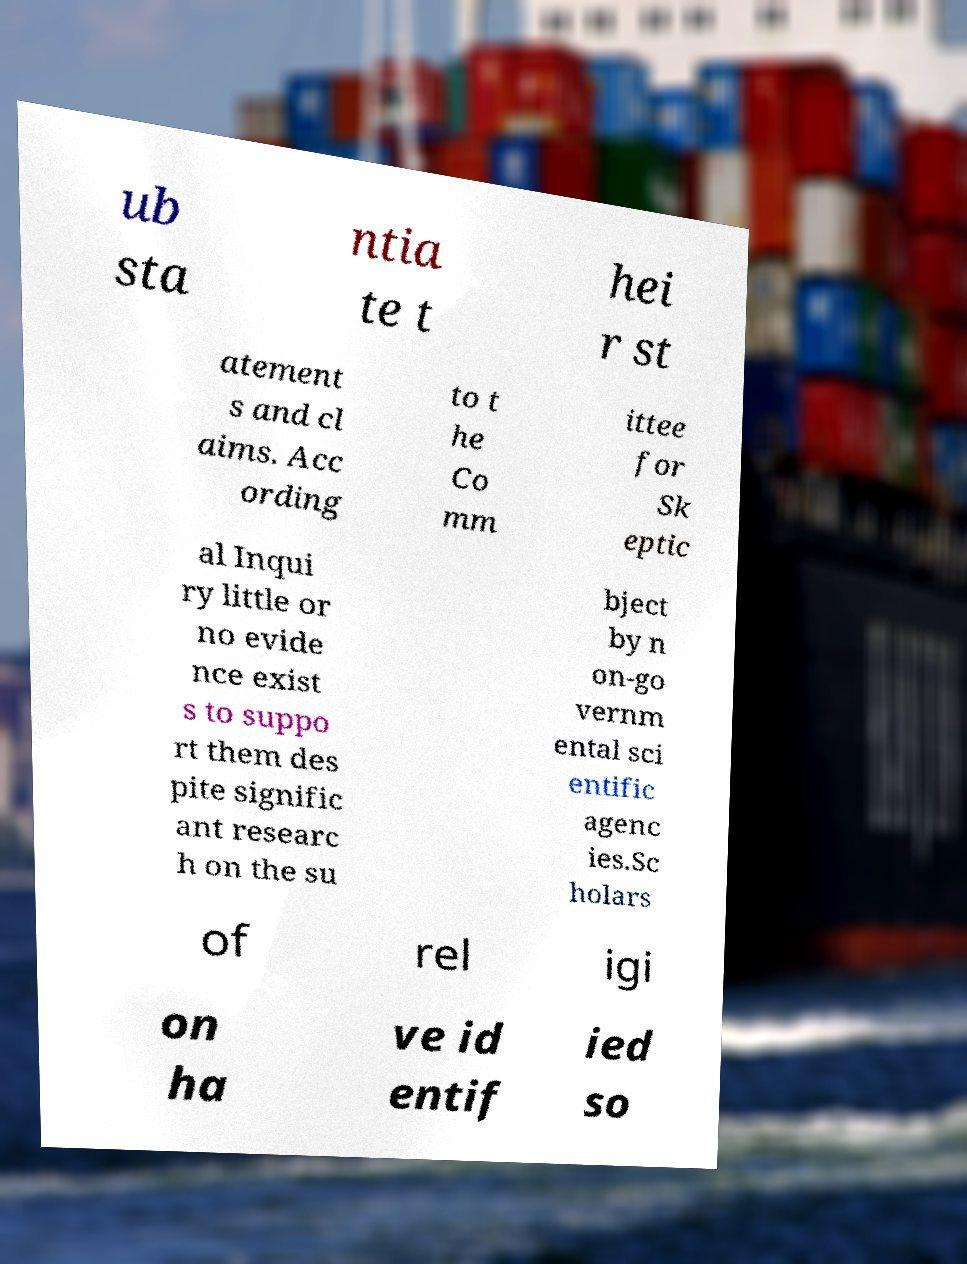Could you assist in decoding the text presented in this image and type it out clearly? ub sta ntia te t hei r st atement s and cl aims. Acc ording to t he Co mm ittee for Sk eptic al Inqui ry little or no evide nce exist s to suppo rt them des pite signific ant researc h on the su bject by n on-go vernm ental sci entific agenc ies.Sc holars of rel igi on ha ve id entif ied so 